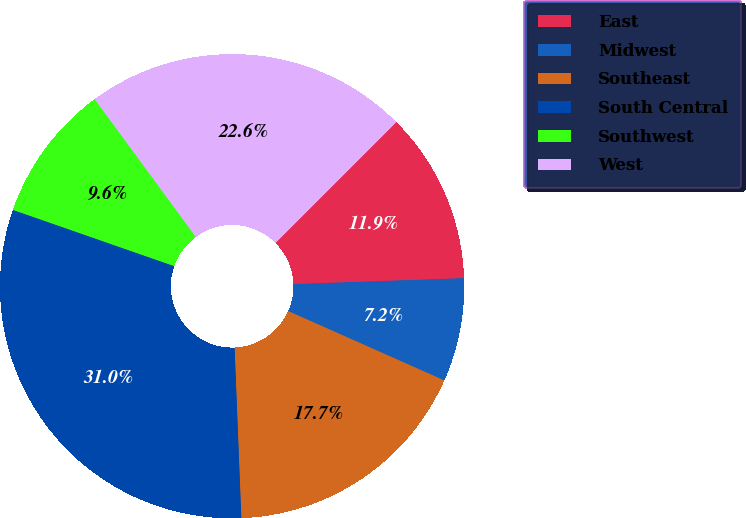<chart> <loc_0><loc_0><loc_500><loc_500><pie_chart><fcel>East<fcel>Midwest<fcel>Southeast<fcel>South Central<fcel>Southwest<fcel>West<nl><fcel>11.95%<fcel>7.2%<fcel>17.72%<fcel>30.97%<fcel>9.58%<fcel>22.58%<nl></chart> 